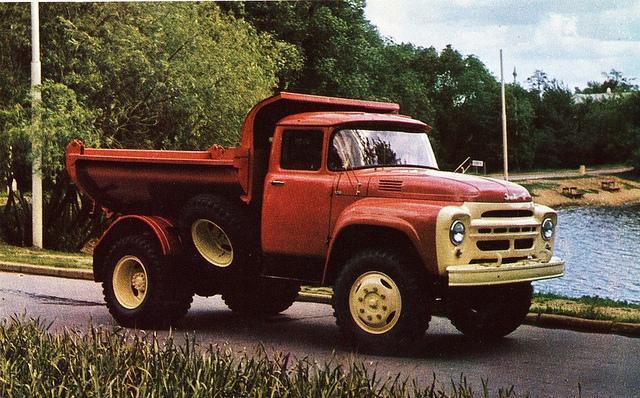How many people are in the scene?
Give a very brief answer. 0. 